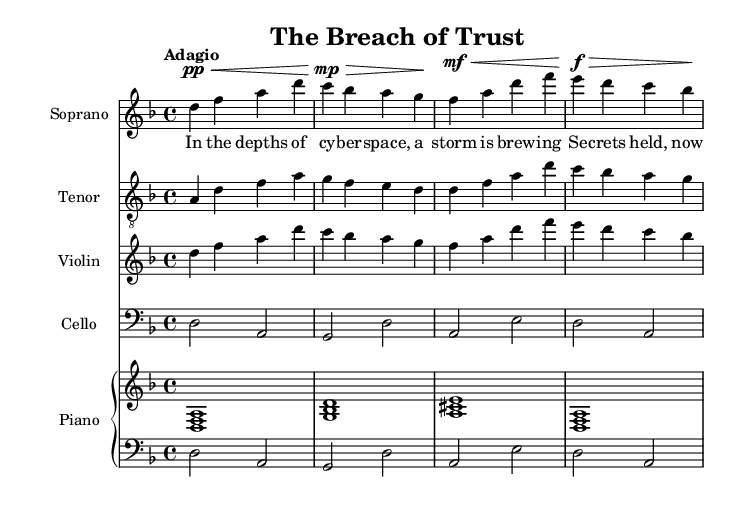What is the key signature of this music? The key signature is D minor, which has one flat (B flat). This can be identified by looking at the beginning of the staff where the flat symbol is placed, indicating the key.
Answer: D minor What is the time signature of this music? The time signature is 4/4, shown at the beginning of the score. This indicates that there are four beats in each measure, and the quarter note gets one beat.
Answer: 4/4 What is the tempo marking for this piece? The tempo marking is "Adagio," which means to play slowly. This information is found at the beginning of the score, indicating the pace of the piece.
Answer: Adagio Which instrument has the highest pitch in the score? The soprano typically has the highest pitch among the instruments shown here. By comparing the ranges of the soprano and other instruments, we can deduce that the soprano sings higher notes than the tenor, violin, cello, and piano.
Answer: Soprano How many measures are in the soprano part? There are four measures in the soprano part, identifiable by counting the groups of vertical bars (measure lines) that separate the notes.
Answer: Four What is the vocal range shown in this score? The vocal range indicated is a soprano range, as identified by the clef used (treble clef) and the higher pitches of the notes. Soprano ranges are typically classified by their upper pitches, which are prominent in this part.
Answer: Soprano What thematic element does the verse reflect? The verse reflects themes of secrets and turmoil, evident from the lyrics which mention cyber space and secrets scattered to the wind, suggesting a dramatic situation related to a data breach.
Answer: Secrets and turmoil 